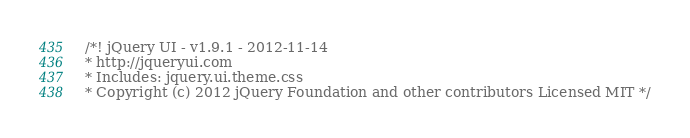Convert code to text. <code><loc_0><loc_0><loc_500><loc_500><_CSS_>/*! jQuery UI - v1.9.1 - 2012-11-14
* http://jqueryui.com
* Includes: jquery.ui.theme.css
* Copyright (c) 2012 jQuery Foundation and other contributors Licensed MIT */</code> 